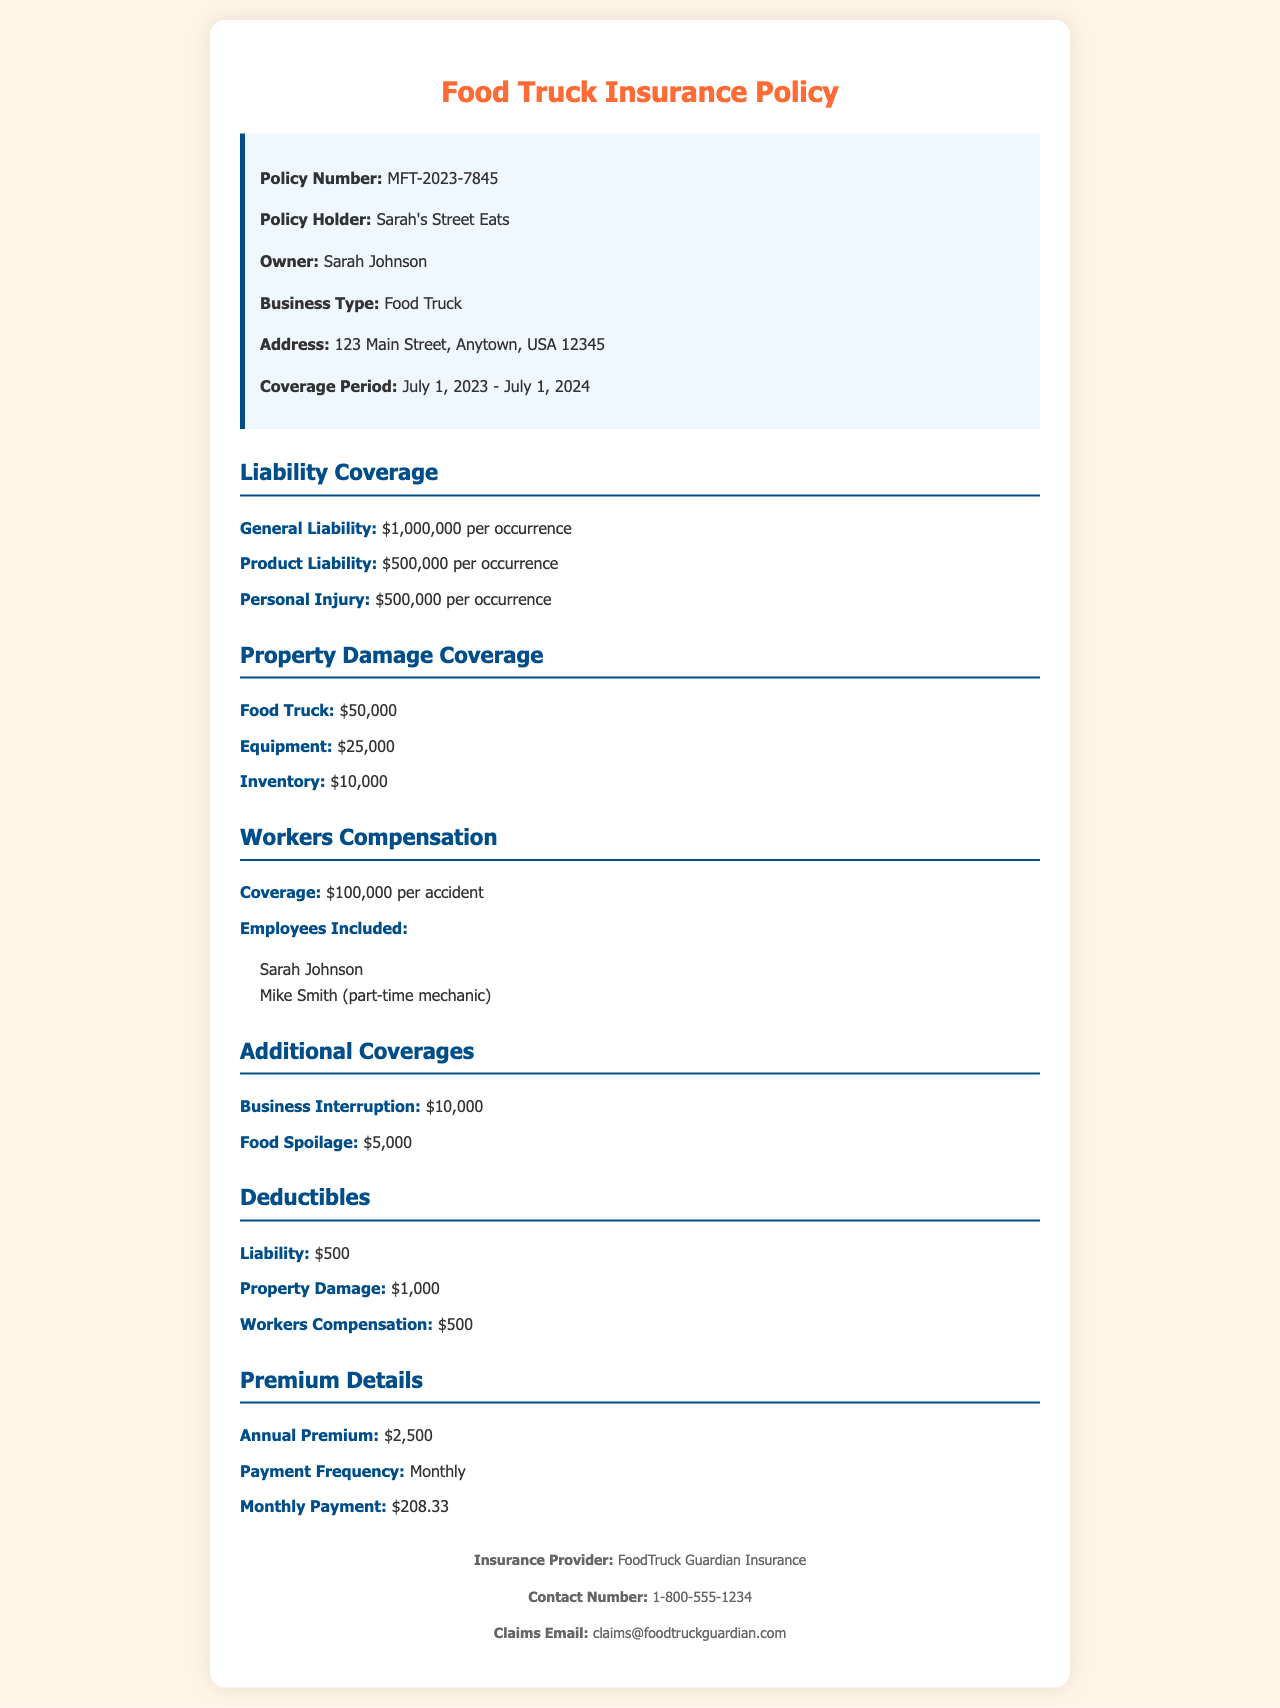What is the policy number? The policy number is listed as the unique identifier for the document, which is MFT-2023-7845.
Answer: MFT-2023-7845 What is the general liability coverage amount? The general liability coverage amount is stated in the document as $1,000,000 per occurrence.
Answer: $1,000,000 per occurrence Who is the owner of Sarah's Street Eats? The document specifies the owner of the business, which is Sarah Johnson.
Answer: Sarah Johnson What is the coverage period for this insurance policy? The coverage period indicates the start and end dates of the policy, which is July 1, 2023 - July 1, 2024.
Answer: July 1, 2023 - July 1, 2024 How much is the monthly payment for the insurance policy? The monthly payment is noted in the premium details as $208.33.
Answer: $208.33 What is the total property damage coverage for the food truck? The total property damage coverage for the food truck is found in the document as $50,000.
Answer: $50,000 How many employees are included in the workers’ compensation coverage? The document lists the employees included, and there are two employees mentioned.
Answer: Two What is the deductible amount for property damage? The deductible amount for property damage is stated as $1,000 in the policy.
Answer: $1,000 What is the annual premium amount? The annual premium amount is clearly specified in the premium details as $2,500.
Answer: $2,500 